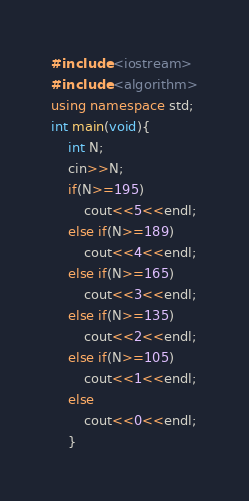Convert code to text. <code><loc_0><loc_0><loc_500><loc_500><_C++_>#include <iostream>
#include <algorithm>
using namespace std;
int main(void){
    int N;
    cin>>N;
    if(N>=195)
        cout<<5<<endl;
    else if(N>=189)
        cout<<4<<endl;
    else if(N>=165)
        cout<<3<<endl;
    else if(N>=135)
        cout<<2<<endl;
    else if(N>=105)
        cout<<1<<endl;
    else 
        cout<<0<<endl;
    }</code> 